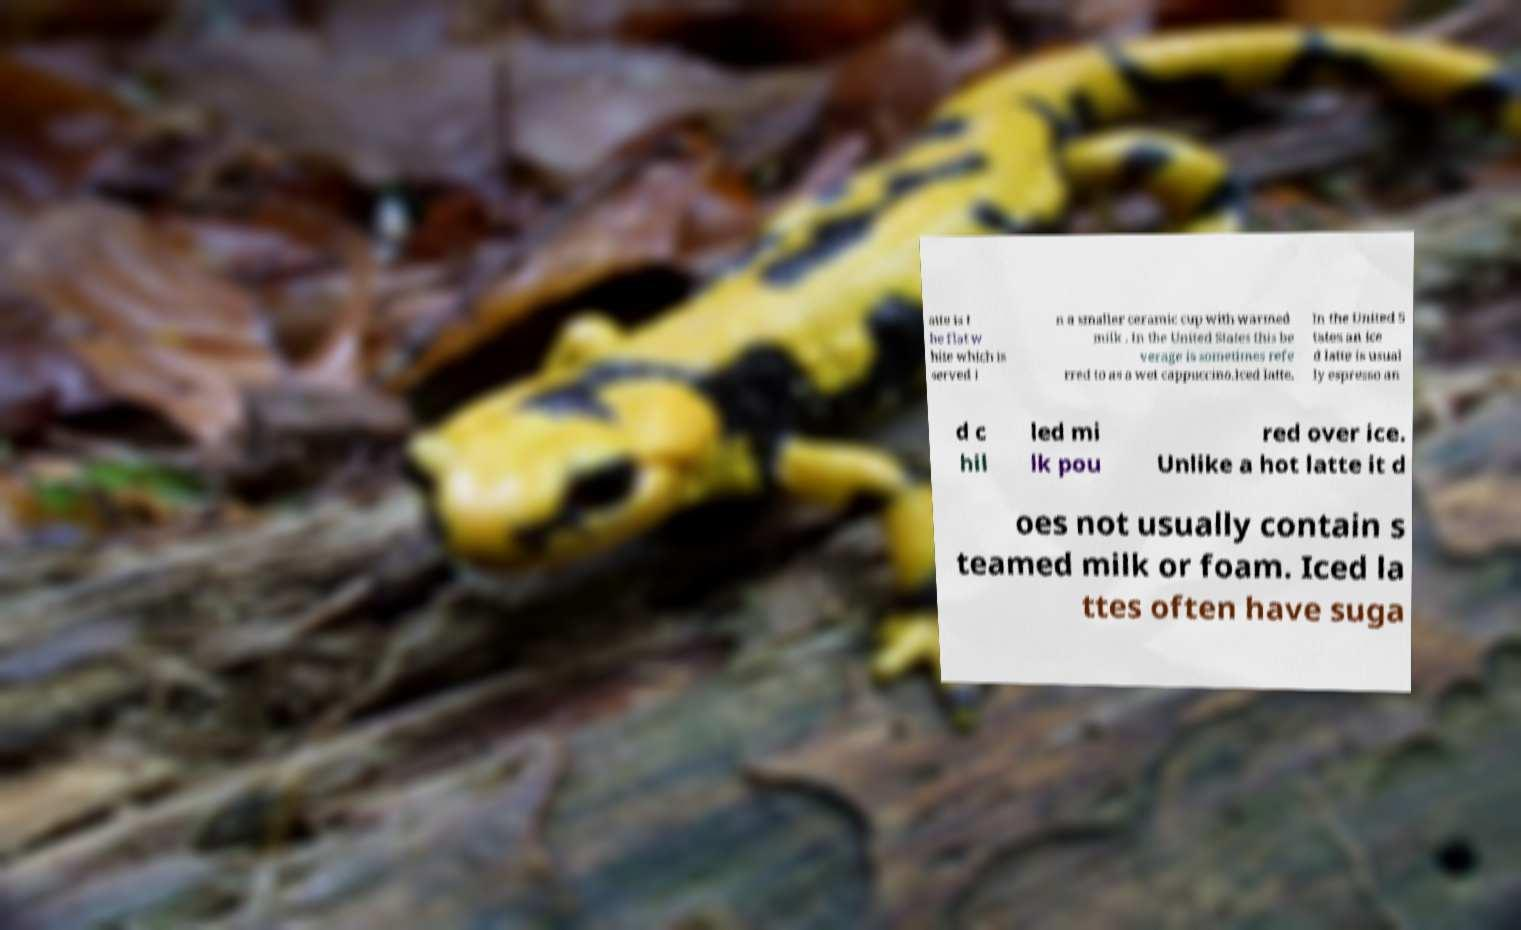Please read and relay the text visible in this image. What does it say? atte is t he flat w hite which is served i n a smaller ceramic cup with warmed milk . In the United States this be verage is sometimes refe rred to as a wet cappuccino.Iced latte. In the United S tates an ice d latte is usual ly espresso an d c hil led mi lk pou red over ice. Unlike a hot latte it d oes not usually contain s teamed milk or foam. Iced la ttes often have suga 